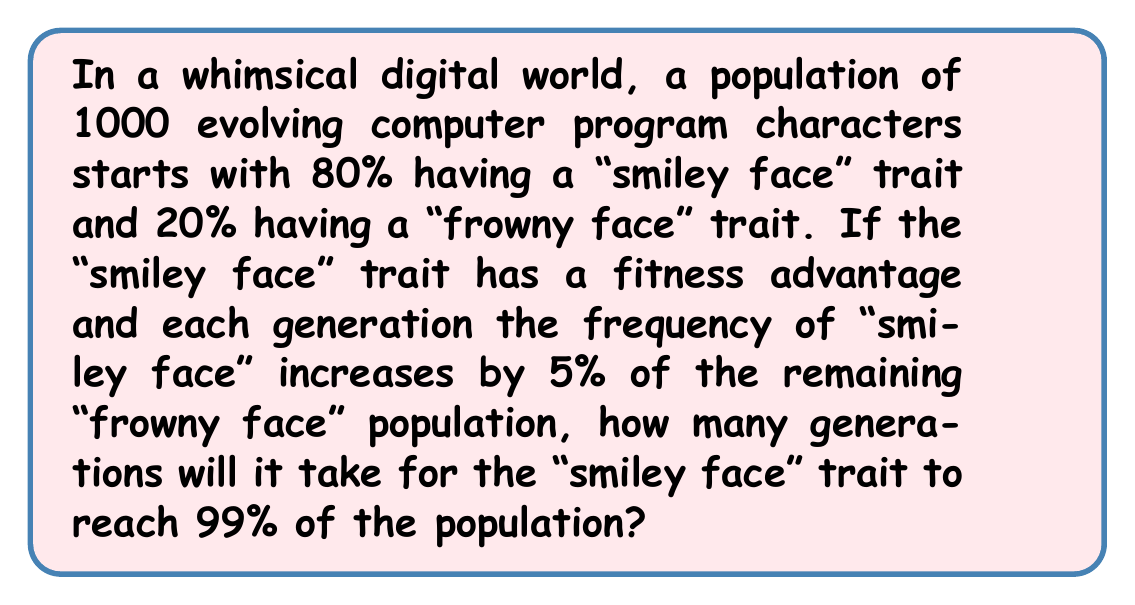Show me your answer to this math problem. Let's approach this step-by-step:

1) Let $p_n$ be the proportion of "smiley face" characters in generation $n$.
   We start with $p_0 = 0.80$ or 80%.

2) In each generation, the increase in "smiley face" proportion is 5% of the remaining "frowny face" proportion.
   This can be expressed as: $p_{n+1} = p_n + 0.05(1-p_n)$

3) We can rewrite this as: $p_{n+1} = 0.95p_n + 0.05$

4) We want to find $n$ when $p_n \geq 0.99$

5) Let's calculate a few generations:
   $p_1 = 0.95(0.80) + 0.05 = 0.81$
   $p_2 = 0.95(0.81) + 0.05 = 0.8195$
   $p_3 = 0.95(0.8195) + 0.05 = 0.828525$

6) We can see this is converging, but slowly. Let's use the formula to find the exact solution:

   $p_n = 1 - 0.2 \cdot 0.95^n$

7) We want to solve: $1 - 0.2 \cdot 0.95^n \geq 0.99$

8) Solving for $n$:
   $0.2 \cdot 0.95^n \leq 0.01$
   $0.95^n \leq 0.05$
   $n \cdot \log(0.95) \leq \log(0.05)$
   $n \geq \frac{\log(0.05)}{\log(0.95)} \approx 58.4$

9) Since $n$ must be a whole number of generations, we round up to 59.
Answer: It will take 59 generations for the "smiley face" trait to reach at least 99% of the population. 